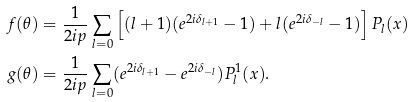<formula> <loc_0><loc_0><loc_500><loc_500>f ( \theta ) & = \frac { 1 } { 2 i p } \sum _ { l = 0 } \left [ ( l + 1 ) ( e ^ { 2 i \delta _ { l + 1 } } - 1 ) + l ( e ^ { 2 i \delta _ { - l } } - 1 ) \right ] P _ { l } ( x ) \\ g ( \theta ) & = \frac { 1 } { 2 i p } \sum _ { l = 0 } ( e ^ { 2 i \delta _ { l + 1 } } - e ^ { 2 i \delta _ { - l } } ) P ^ { 1 } _ { l } ( x ) .</formula> 